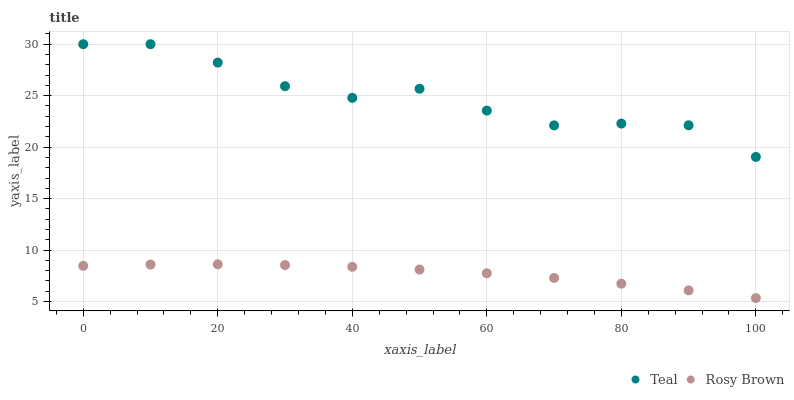Does Rosy Brown have the minimum area under the curve?
Answer yes or no. Yes. Does Teal have the maximum area under the curve?
Answer yes or no. Yes. Does Teal have the minimum area under the curve?
Answer yes or no. No. Is Rosy Brown the smoothest?
Answer yes or no. Yes. Is Teal the roughest?
Answer yes or no. Yes. Is Teal the smoothest?
Answer yes or no. No. Does Rosy Brown have the lowest value?
Answer yes or no. Yes. Does Teal have the lowest value?
Answer yes or no. No. Does Teal have the highest value?
Answer yes or no. Yes. Is Rosy Brown less than Teal?
Answer yes or no. Yes. Is Teal greater than Rosy Brown?
Answer yes or no. Yes. Does Rosy Brown intersect Teal?
Answer yes or no. No. 